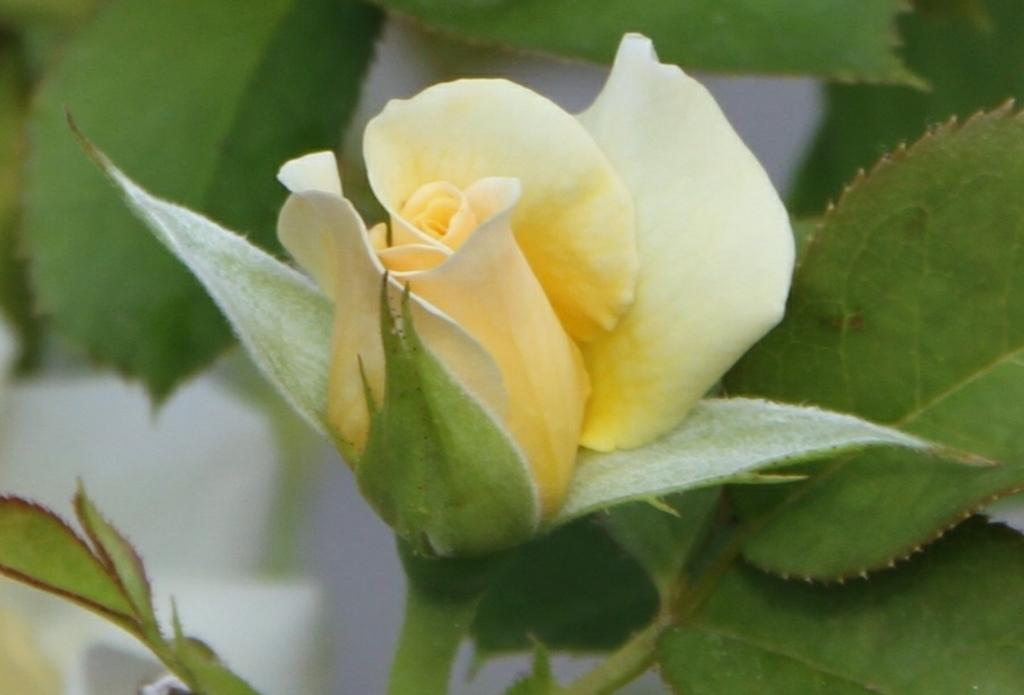What is the main subject in the center of the image? There is a rose in the center of the image. What can be seen around the main subject? There are leaves around the area of the image. What type of appliance can be seen in the image? There is no appliance present in the image; it features a rose and leaves. What does the tongue of the rose look like in the image? Roses do not have tongues, so this detail cannot be observed in the image. 